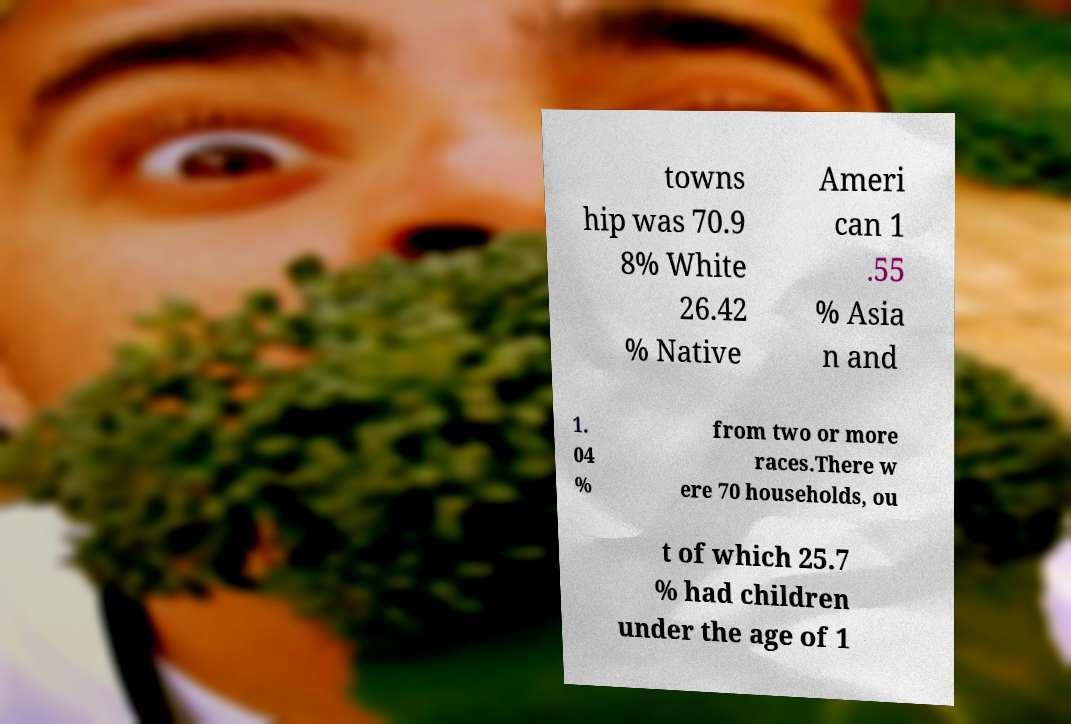Can you read and provide the text displayed in the image?This photo seems to have some interesting text. Can you extract and type it out for me? towns hip was 70.9 8% White 26.42 % Native Ameri can 1 .55 % Asia n and 1. 04 % from two or more races.There w ere 70 households, ou t of which 25.7 % had children under the age of 1 